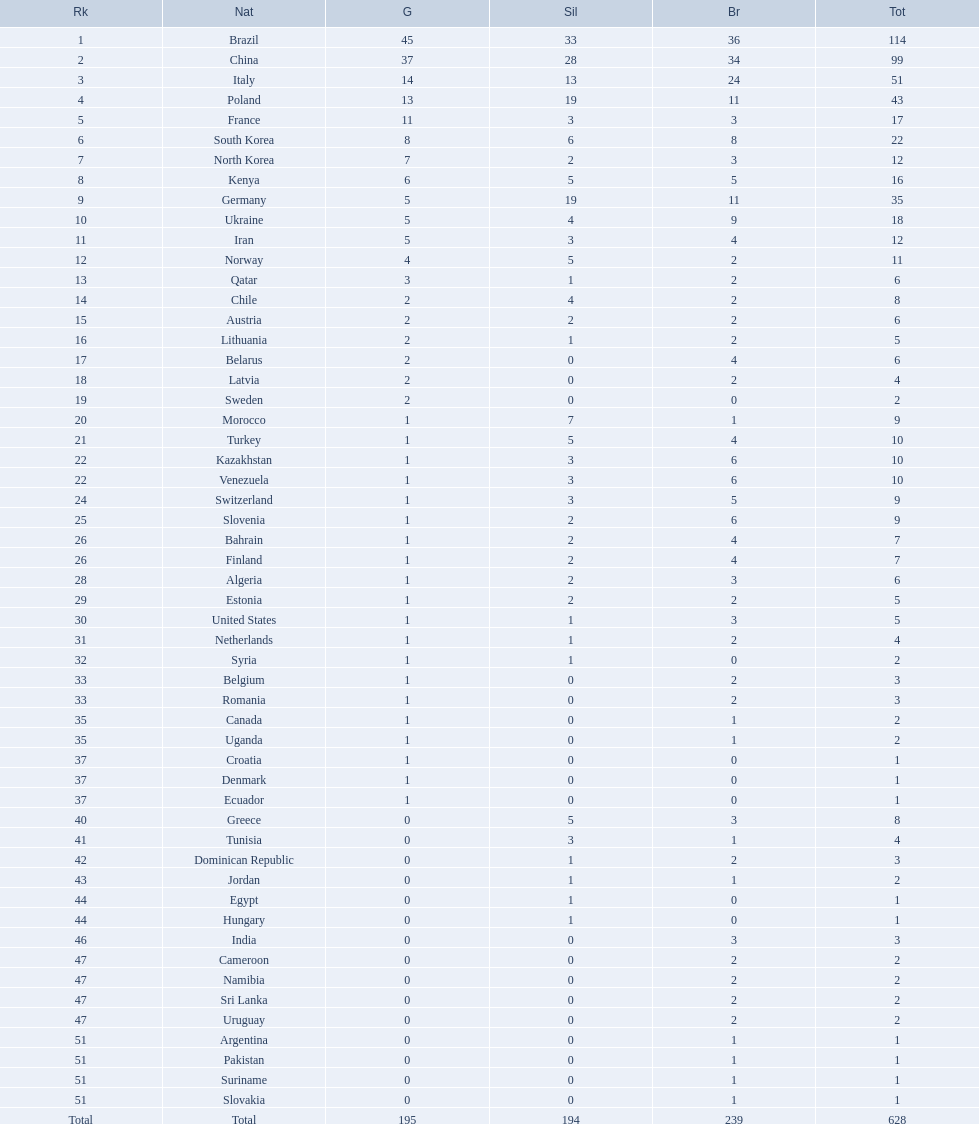Who won more gold medals, brazil or china? Brazil. 